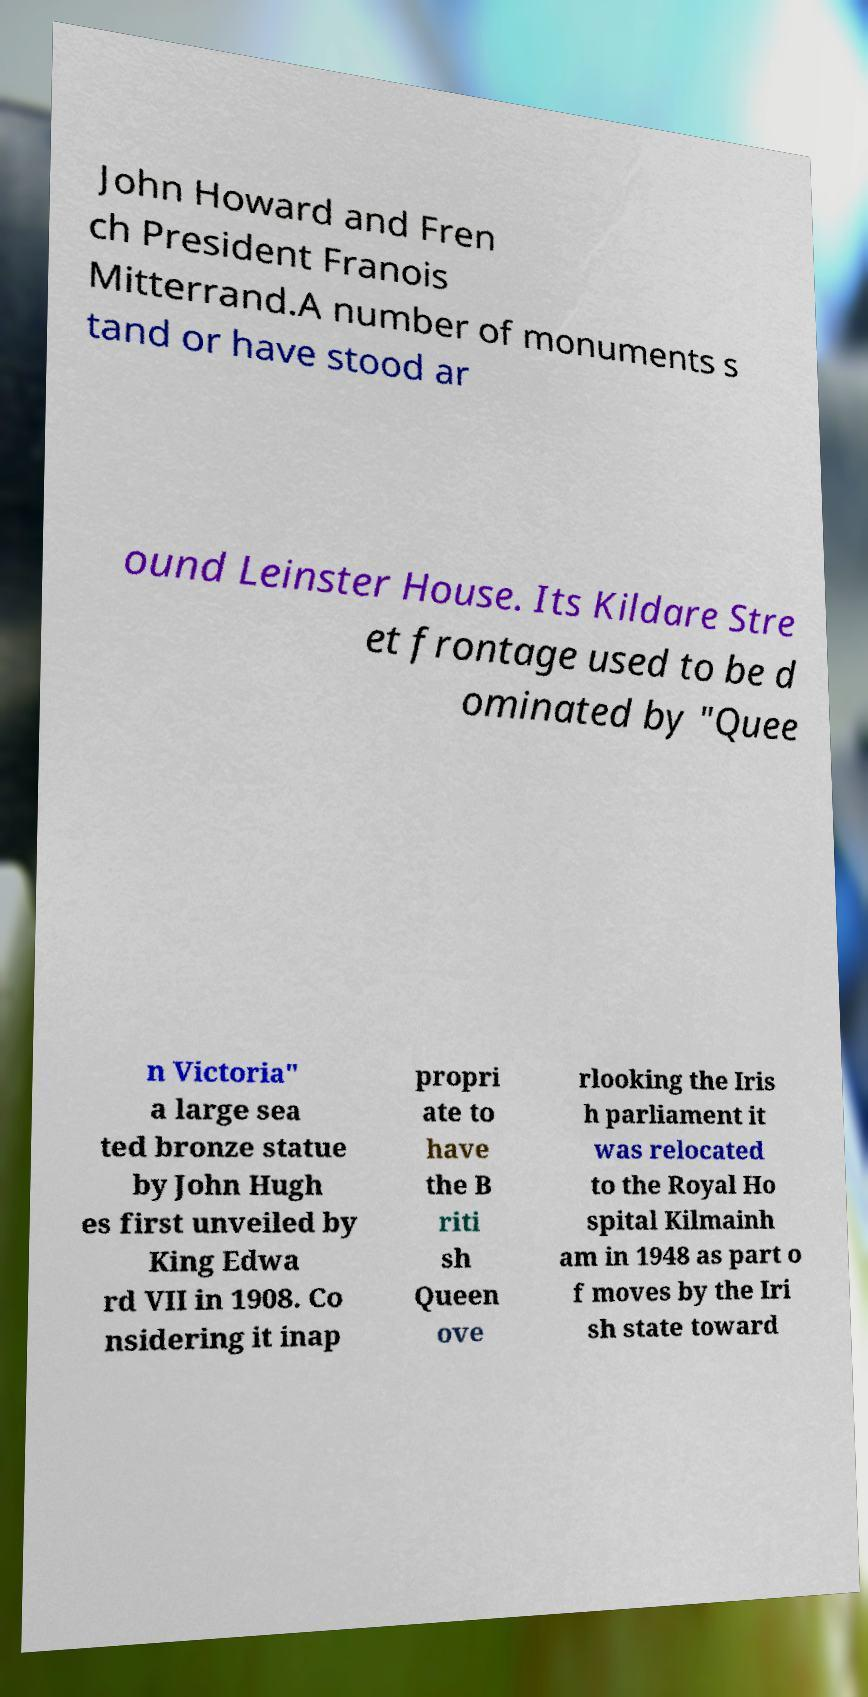Can you read and provide the text displayed in the image?This photo seems to have some interesting text. Can you extract and type it out for me? John Howard and Fren ch President Franois Mitterrand.A number of monuments s tand or have stood ar ound Leinster House. Its Kildare Stre et frontage used to be d ominated by "Quee n Victoria" a large sea ted bronze statue by John Hugh es first unveiled by King Edwa rd VII in 1908. Co nsidering it inap propri ate to have the B riti sh Queen ove rlooking the Iris h parliament it was relocated to the Royal Ho spital Kilmainh am in 1948 as part o f moves by the Iri sh state toward 